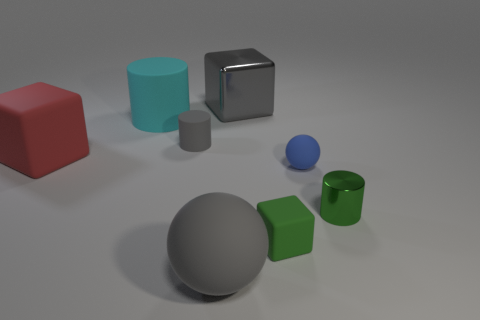Are there any other things that have the same color as the tiny matte sphere?
Your response must be concise. No. There is a large gray object that is behind the tiny matte cylinder; what material is it?
Ensure brevity in your answer.  Metal. What number of other objects are there of the same size as the red matte thing?
Provide a short and direct response. 3. Is the size of the gray cylinder the same as the gray thing that is behind the big cyan cylinder?
Provide a succinct answer. No. There is a small object that is on the left side of the big gray object in front of the tiny green object that is on the right side of the green rubber object; what is its shape?
Provide a succinct answer. Cylinder. Is the number of small gray matte spheres less than the number of big gray cubes?
Provide a succinct answer. Yes. There is a small rubber cube; are there any green objects in front of it?
Ensure brevity in your answer.  No. What shape is the object that is right of the big gray sphere and behind the tiny blue object?
Offer a terse response. Cube. Are there any other matte objects of the same shape as the small gray thing?
Your response must be concise. Yes. Is the size of the metallic object that is behind the gray cylinder the same as the gray thing that is in front of the tiny shiny cylinder?
Offer a very short reply. Yes. 